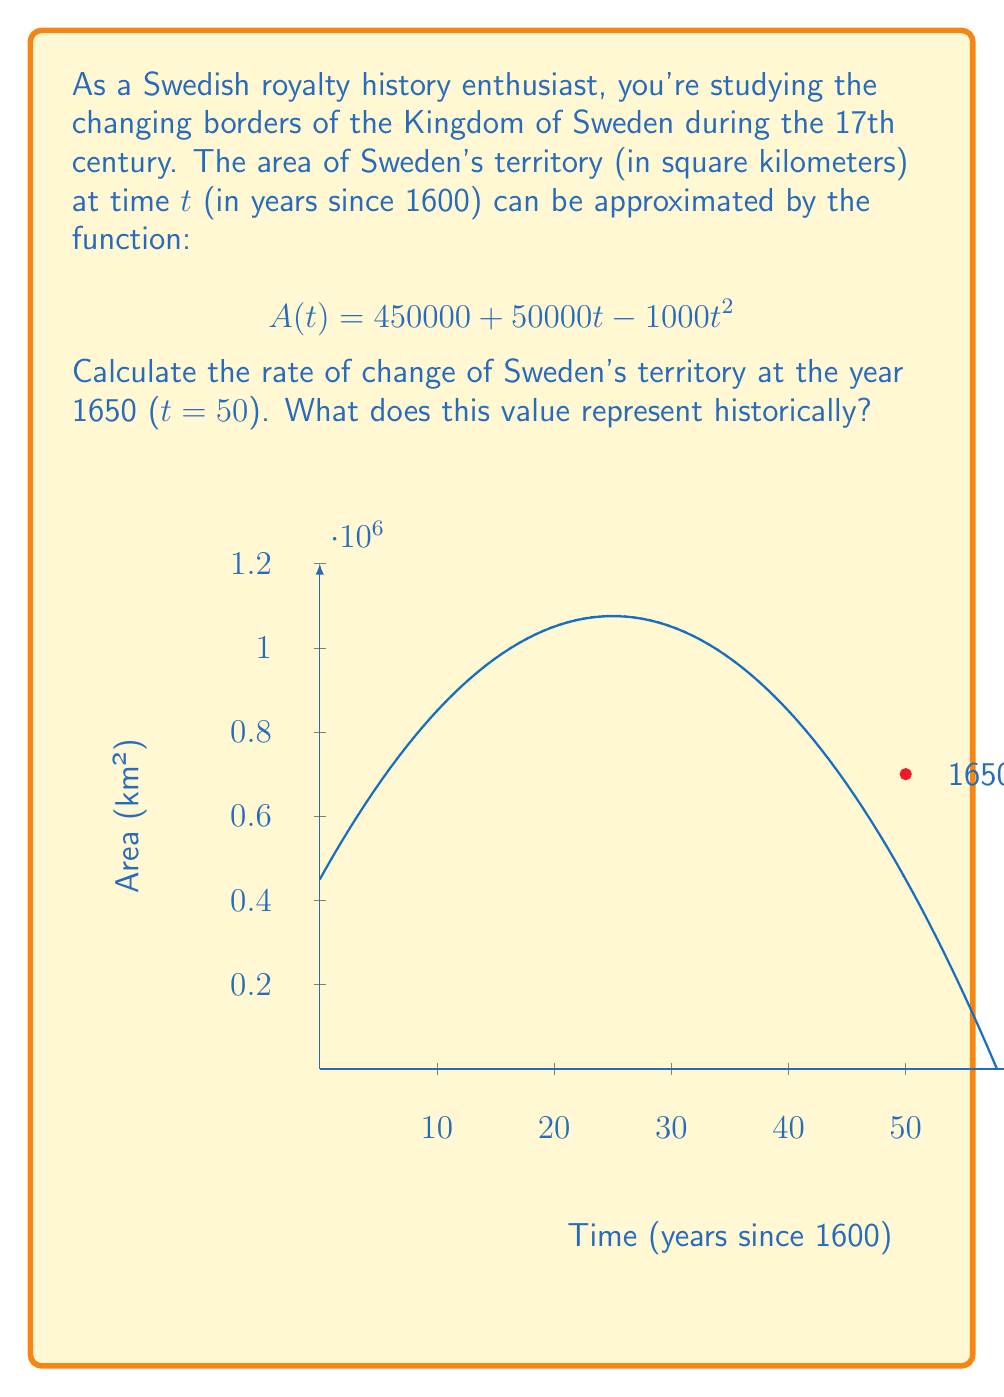What is the answer to this math problem? To solve this problem, we need to follow these steps:

1) The rate of change of the area is given by the derivative of $A(t)$ with respect to $t$.

2) Let's calculate the derivative $A'(t)$:
   $$A(t) = 450000 + 50000t - 1000t^2$$
   $$A'(t) = 50000 - 2000t$$

3) Now, we need to evaluate $A'(t)$ at $t = 50$ (corresponding to the year 1650):
   $$A'(50) = 50000 - 2000(50) = 50000 - 100000 = -50000$$

4) The negative value indicates that the territory was decreasing at this point in time.

5) To interpret this historically:
   The rate of change of -50,000 km²/year means that in 1650, Sweden's territory was shrinking at a rate of 50,000 square kilometers per year. This could correspond to the period after the Thirty Years' War (1618-1648), during which Sweden had gained significant territory but was now facing challenges in maintaining its expanded empire.
Answer: $-50000$ km²/year, representing a shrinking territory in 1650. 